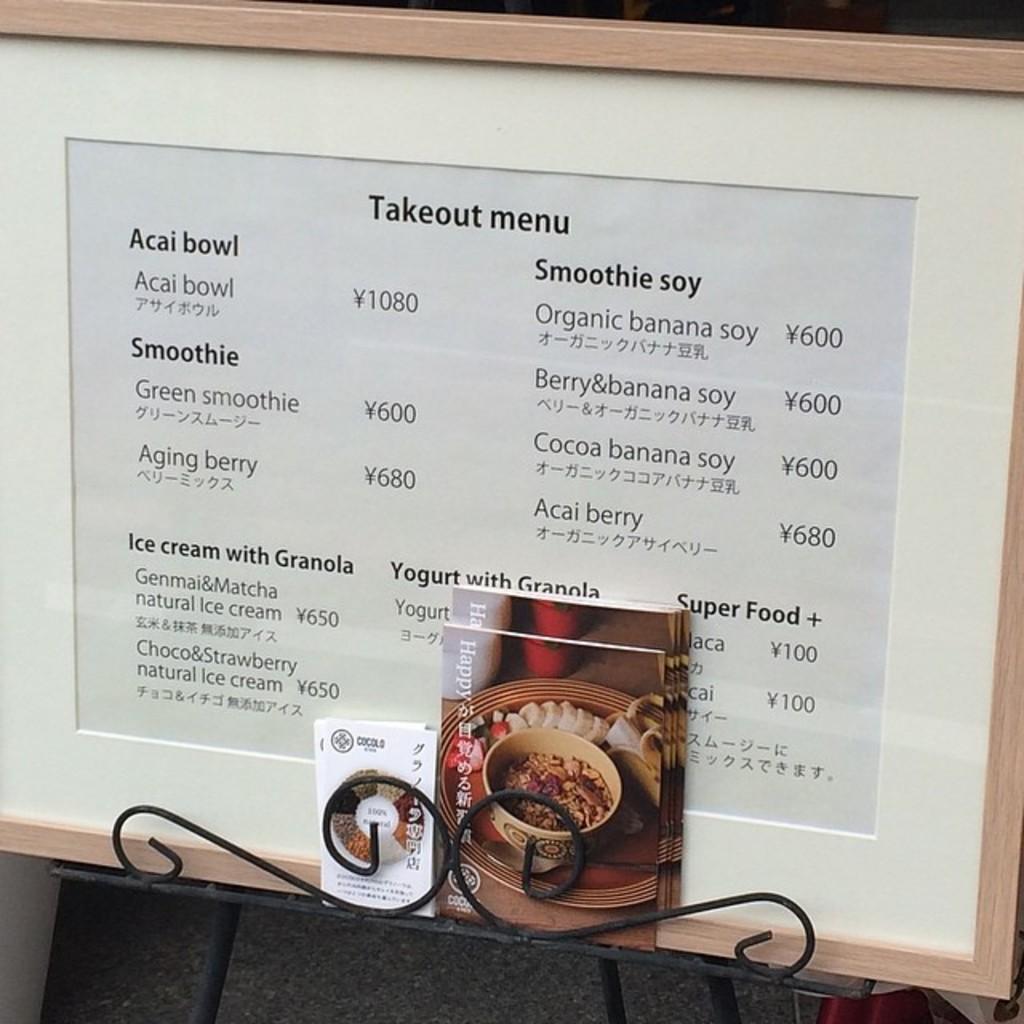In one or two sentences, can you explain what this image depicts? In the image we can see some books and frame on a table. 